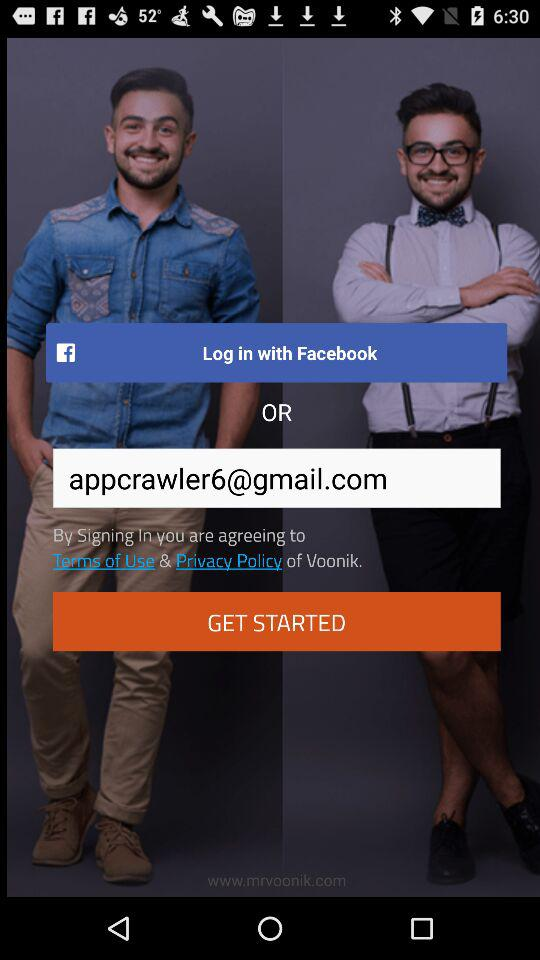What are the different options available for logging in? The available option for logging in is "Facebook". 